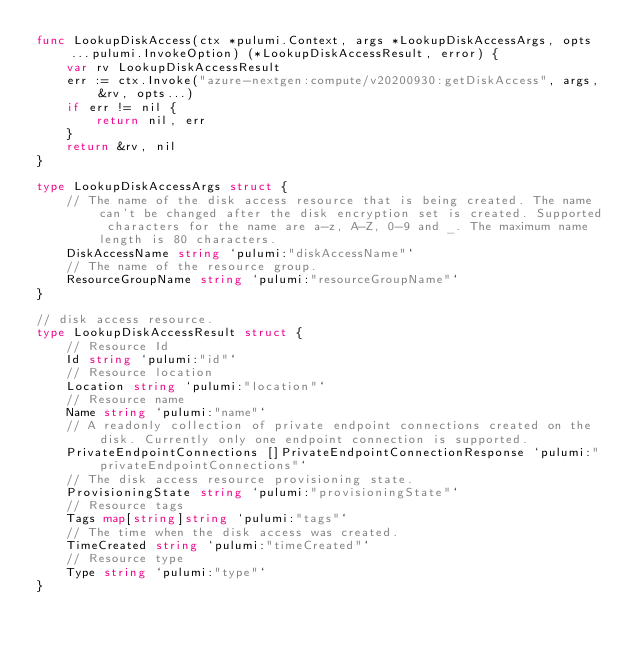Convert code to text. <code><loc_0><loc_0><loc_500><loc_500><_Go_>func LookupDiskAccess(ctx *pulumi.Context, args *LookupDiskAccessArgs, opts ...pulumi.InvokeOption) (*LookupDiskAccessResult, error) {
	var rv LookupDiskAccessResult
	err := ctx.Invoke("azure-nextgen:compute/v20200930:getDiskAccess", args, &rv, opts...)
	if err != nil {
		return nil, err
	}
	return &rv, nil
}

type LookupDiskAccessArgs struct {
	// The name of the disk access resource that is being created. The name can't be changed after the disk encryption set is created. Supported characters for the name are a-z, A-Z, 0-9 and _. The maximum name length is 80 characters.
	DiskAccessName string `pulumi:"diskAccessName"`
	// The name of the resource group.
	ResourceGroupName string `pulumi:"resourceGroupName"`
}

// disk access resource.
type LookupDiskAccessResult struct {
	// Resource Id
	Id string `pulumi:"id"`
	// Resource location
	Location string `pulumi:"location"`
	// Resource name
	Name string `pulumi:"name"`
	// A readonly collection of private endpoint connections created on the disk. Currently only one endpoint connection is supported.
	PrivateEndpointConnections []PrivateEndpointConnectionResponse `pulumi:"privateEndpointConnections"`
	// The disk access resource provisioning state.
	ProvisioningState string `pulumi:"provisioningState"`
	// Resource tags
	Tags map[string]string `pulumi:"tags"`
	// The time when the disk access was created.
	TimeCreated string `pulumi:"timeCreated"`
	// Resource type
	Type string `pulumi:"type"`
}
</code> 